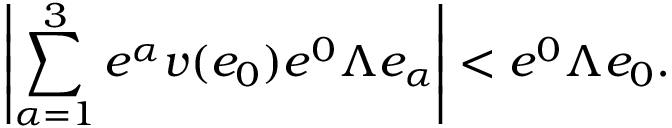Convert formula to latex. <formula><loc_0><loc_0><loc_500><loc_500>\left | \sum _ { \alpha = 1 } ^ { 3 } e ^ { \alpha } v ( e _ { 0 } ) e ^ { 0 } \Lambda e _ { \alpha } \right | < e ^ { 0 } \Lambda e _ { 0 } .</formula> 